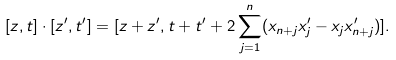Convert formula to latex. <formula><loc_0><loc_0><loc_500><loc_500>[ z , t ] \cdot [ z ^ { \prime } , t ^ { \prime } ] = [ z + z ^ { \prime } , t + t ^ { \prime } + 2 \sum _ { j = 1 } ^ { n } ( x _ { n + j } x ^ { \prime } _ { j } - x _ { j } x ^ { \prime } _ { n + j } ) ] .</formula> 